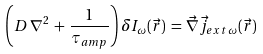<formula> <loc_0><loc_0><loc_500><loc_500>\left ( D \, \nabla ^ { 2 } \, + \, \frac { 1 } { \tau _ { a m p } } \right ) \delta I _ { \omega } ( \vec { r } ) \, = \, \vec { \nabla } \vec { j } _ { e x t \, \omega } ( \vec { r } )</formula> 